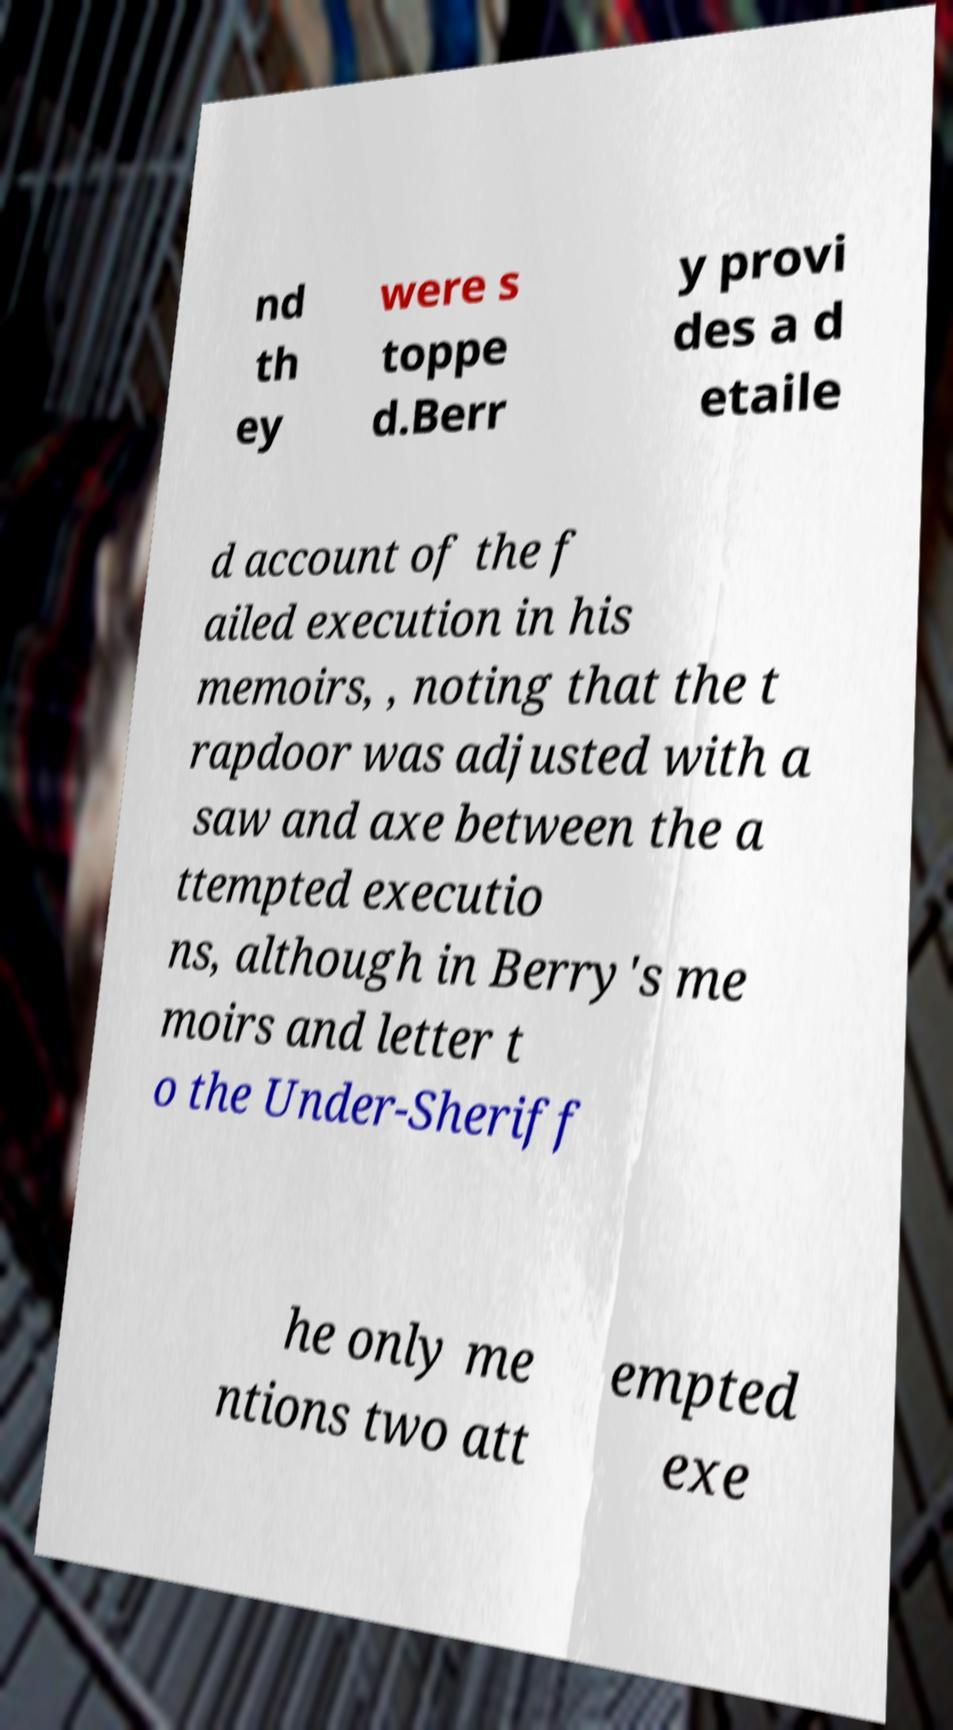There's text embedded in this image that I need extracted. Can you transcribe it verbatim? nd th ey were s toppe d.Berr y provi des a d etaile d account of the f ailed execution in his memoirs, , noting that the t rapdoor was adjusted with a saw and axe between the a ttempted executio ns, although in Berry's me moirs and letter t o the Under-Sheriff he only me ntions two att empted exe 